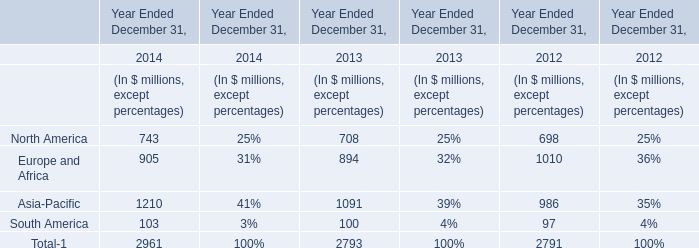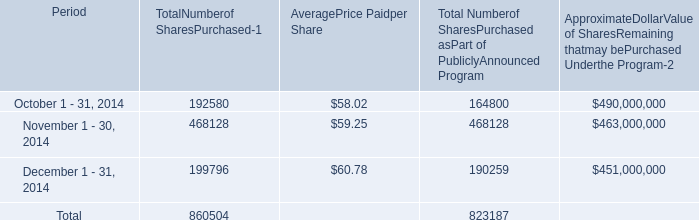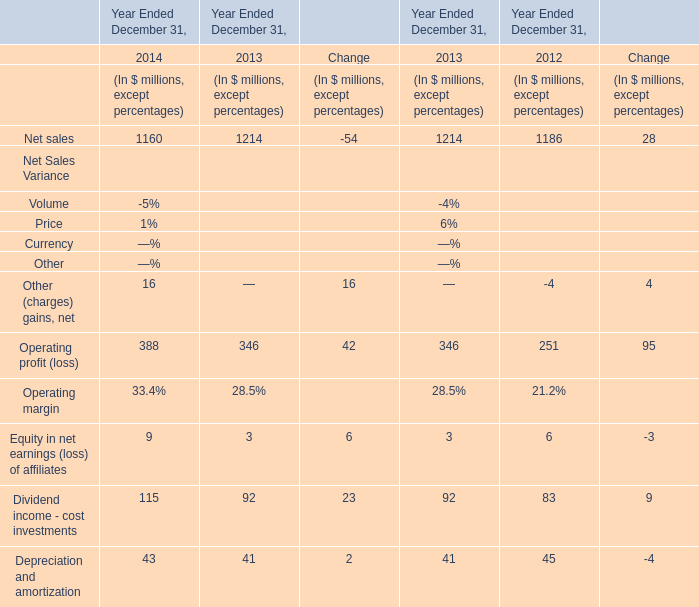Does net sales keeps increasing each year between 2012 and 2013? 
Answer: yes. 